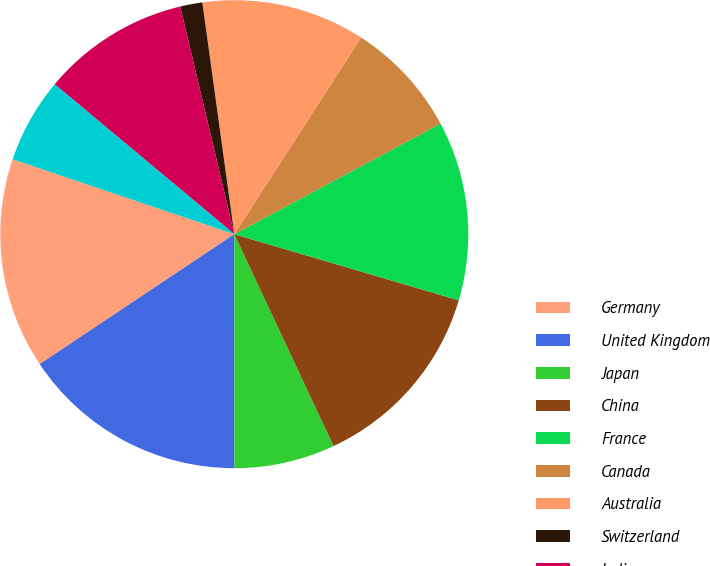Convert chart. <chart><loc_0><loc_0><loc_500><loc_500><pie_chart><fcel>Germany<fcel>United Kingdom<fcel>Japan<fcel>China<fcel>France<fcel>Canada<fcel>Australia<fcel>Switzerland<fcel>India<fcel>South Korea<nl><fcel>14.56%<fcel>15.64%<fcel>6.96%<fcel>13.47%<fcel>12.39%<fcel>8.05%<fcel>11.3%<fcel>1.53%<fcel>10.22%<fcel>5.88%<nl></chart> 